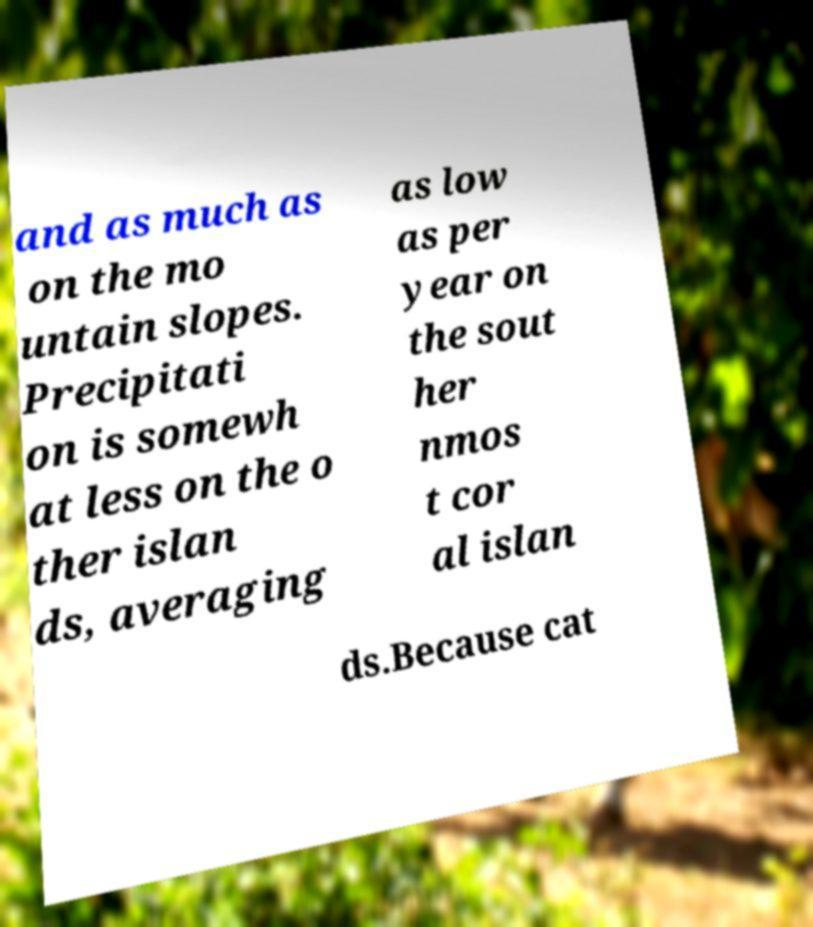Could you extract and type out the text from this image? and as much as on the mo untain slopes. Precipitati on is somewh at less on the o ther islan ds, averaging as low as per year on the sout her nmos t cor al islan ds.Because cat 